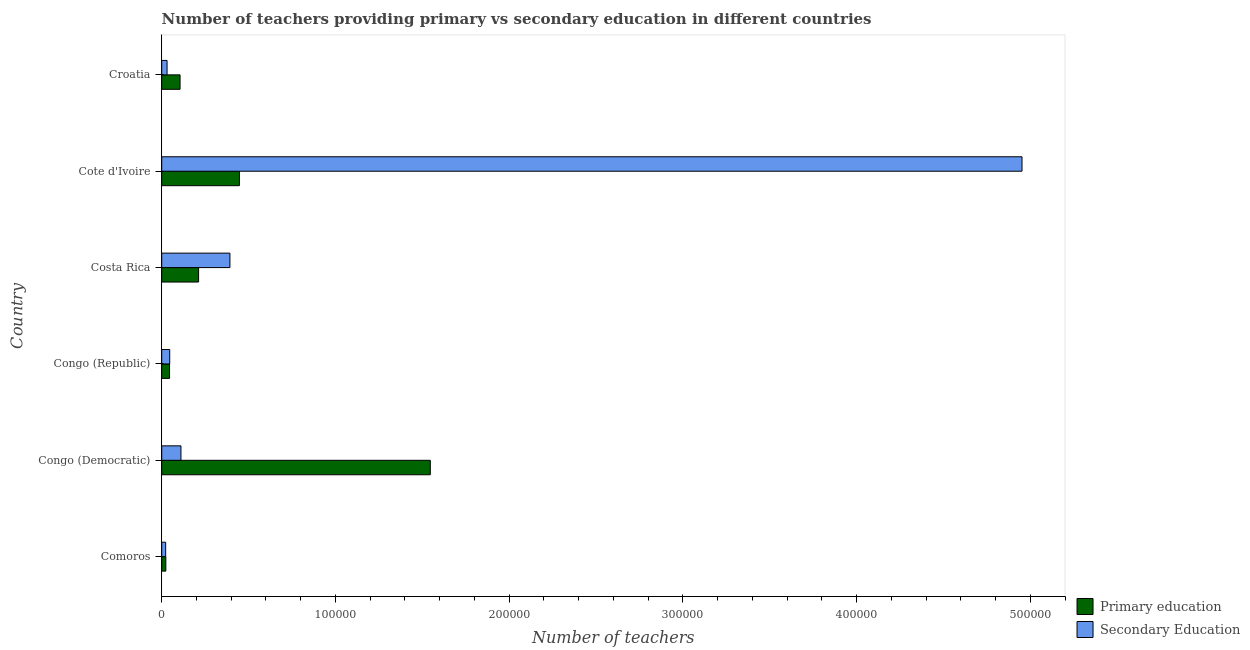Are the number of bars per tick equal to the number of legend labels?
Give a very brief answer. Yes. What is the label of the 2nd group of bars from the top?
Provide a succinct answer. Cote d'Ivoire. What is the number of secondary teachers in Croatia?
Your answer should be compact. 3078. Across all countries, what is the maximum number of primary teachers?
Give a very brief answer. 1.55e+05. Across all countries, what is the minimum number of primary teachers?
Offer a terse response. 2381. In which country was the number of secondary teachers maximum?
Provide a succinct answer. Cote d'Ivoire. In which country was the number of secondary teachers minimum?
Provide a succinct answer. Comoros. What is the total number of primary teachers in the graph?
Your response must be concise. 2.38e+05. What is the difference between the number of secondary teachers in Costa Rica and that in Croatia?
Provide a succinct answer. 3.62e+04. What is the difference between the number of secondary teachers in Croatia and the number of primary teachers in Congo (Democratic)?
Keep it short and to the point. -1.52e+05. What is the average number of secondary teachers per country?
Make the answer very short. 9.26e+04. What is the difference between the number of secondary teachers and number of primary teachers in Costa Rica?
Make the answer very short. 1.80e+04. What is the ratio of the number of primary teachers in Costa Rica to that in Croatia?
Ensure brevity in your answer.  2.01. Is the number of secondary teachers in Costa Rica less than that in Cote d'Ivoire?
Keep it short and to the point. Yes. What is the difference between the highest and the second highest number of secondary teachers?
Give a very brief answer. 4.56e+05. What is the difference between the highest and the lowest number of secondary teachers?
Offer a terse response. 4.93e+05. In how many countries, is the number of secondary teachers greater than the average number of secondary teachers taken over all countries?
Offer a terse response. 1. Is the sum of the number of primary teachers in Costa Rica and Cote d'Ivoire greater than the maximum number of secondary teachers across all countries?
Offer a very short reply. No. What does the 2nd bar from the top in Cote d'Ivoire represents?
Give a very brief answer. Primary education. What does the 2nd bar from the bottom in Congo (Republic) represents?
Provide a short and direct response. Secondary Education. How many bars are there?
Keep it short and to the point. 12. Are all the bars in the graph horizontal?
Offer a very short reply. Yes. Are the values on the major ticks of X-axis written in scientific E-notation?
Make the answer very short. No. Does the graph contain any zero values?
Ensure brevity in your answer.  No. How many legend labels are there?
Keep it short and to the point. 2. How are the legend labels stacked?
Your answer should be very brief. Vertical. What is the title of the graph?
Offer a very short reply. Number of teachers providing primary vs secondary education in different countries. Does "GDP per capita" appear as one of the legend labels in the graph?
Offer a terse response. No. What is the label or title of the X-axis?
Ensure brevity in your answer.  Number of teachers. What is the Number of teachers of Primary education in Comoros?
Your answer should be compact. 2381. What is the Number of teachers of Secondary Education in Comoros?
Provide a short and direct response. 2278. What is the Number of teachers of Primary education in Congo (Democratic)?
Offer a terse response. 1.55e+05. What is the Number of teachers in Secondary Education in Congo (Democratic)?
Give a very brief answer. 1.11e+04. What is the Number of teachers of Primary education in Congo (Republic)?
Ensure brevity in your answer.  4515. What is the Number of teachers in Secondary Education in Congo (Republic)?
Offer a terse response. 4609. What is the Number of teachers of Primary education in Costa Rica?
Your answer should be very brief. 2.12e+04. What is the Number of teachers of Secondary Education in Costa Rica?
Give a very brief answer. 3.93e+04. What is the Number of teachers in Primary education in Cote d'Ivoire?
Your answer should be very brief. 4.47e+04. What is the Number of teachers of Secondary Education in Cote d'Ivoire?
Provide a succinct answer. 4.95e+05. What is the Number of teachers of Primary education in Croatia?
Offer a terse response. 1.06e+04. What is the Number of teachers in Secondary Education in Croatia?
Provide a short and direct response. 3078. Across all countries, what is the maximum Number of teachers of Primary education?
Your answer should be very brief. 1.55e+05. Across all countries, what is the maximum Number of teachers of Secondary Education?
Provide a succinct answer. 4.95e+05. Across all countries, what is the minimum Number of teachers of Primary education?
Offer a very short reply. 2381. Across all countries, what is the minimum Number of teachers of Secondary Education?
Your answer should be compact. 2278. What is the total Number of teachers in Primary education in the graph?
Keep it short and to the point. 2.38e+05. What is the total Number of teachers in Secondary Education in the graph?
Your response must be concise. 5.56e+05. What is the difference between the Number of teachers in Primary education in Comoros and that in Congo (Democratic)?
Provide a short and direct response. -1.52e+05. What is the difference between the Number of teachers in Secondary Education in Comoros and that in Congo (Democratic)?
Offer a terse response. -8797. What is the difference between the Number of teachers of Primary education in Comoros and that in Congo (Republic)?
Provide a succinct answer. -2134. What is the difference between the Number of teachers in Secondary Education in Comoros and that in Congo (Republic)?
Your answer should be very brief. -2331. What is the difference between the Number of teachers in Primary education in Comoros and that in Costa Rica?
Offer a terse response. -1.89e+04. What is the difference between the Number of teachers of Secondary Education in Comoros and that in Costa Rica?
Your answer should be very brief. -3.70e+04. What is the difference between the Number of teachers in Primary education in Comoros and that in Cote d'Ivoire?
Your answer should be very brief. -4.24e+04. What is the difference between the Number of teachers in Secondary Education in Comoros and that in Cote d'Ivoire?
Make the answer very short. -4.93e+05. What is the difference between the Number of teachers in Primary education in Comoros and that in Croatia?
Your answer should be compact. -8187. What is the difference between the Number of teachers in Secondary Education in Comoros and that in Croatia?
Make the answer very short. -800. What is the difference between the Number of teachers in Primary education in Congo (Democratic) and that in Congo (Republic)?
Make the answer very short. 1.50e+05. What is the difference between the Number of teachers in Secondary Education in Congo (Democratic) and that in Congo (Republic)?
Your answer should be compact. 6466. What is the difference between the Number of teachers in Primary education in Congo (Democratic) and that in Costa Rica?
Your answer should be compact. 1.33e+05. What is the difference between the Number of teachers of Secondary Education in Congo (Democratic) and that in Costa Rica?
Your answer should be very brief. -2.82e+04. What is the difference between the Number of teachers in Primary education in Congo (Democratic) and that in Cote d'Ivoire?
Your answer should be compact. 1.10e+05. What is the difference between the Number of teachers of Secondary Education in Congo (Democratic) and that in Cote d'Ivoire?
Your response must be concise. -4.84e+05. What is the difference between the Number of teachers in Primary education in Congo (Democratic) and that in Croatia?
Keep it short and to the point. 1.44e+05. What is the difference between the Number of teachers of Secondary Education in Congo (Democratic) and that in Croatia?
Provide a succinct answer. 7997. What is the difference between the Number of teachers of Primary education in Congo (Republic) and that in Costa Rica?
Provide a succinct answer. -1.67e+04. What is the difference between the Number of teachers in Secondary Education in Congo (Republic) and that in Costa Rica?
Give a very brief answer. -3.47e+04. What is the difference between the Number of teachers in Primary education in Congo (Republic) and that in Cote d'Ivoire?
Provide a short and direct response. -4.02e+04. What is the difference between the Number of teachers of Secondary Education in Congo (Republic) and that in Cote d'Ivoire?
Give a very brief answer. -4.91e+05. What is the difference between the Number of teachers of Primary education in Congo (Republic) and that in Croatia?
Ensure brevity in your answer.  -6053. What is the difference between the Number of teachers of Secondary Education in Congo (Republic) and that in Croatia?
Offer a terse response. 1531. What is the difference between the Number of teachers of Primary education in Costa Rica and that in Cote d'Ivoire?
Your answer should be compact. -2.35e+04. What is the difference between the Number of teachers in Secondary Education in Costa Rica and that in Cote d'Ivoire?
Your answer should be compact. -4.56e+05. What is the difference between the Number of teachers of Primary education in Costa Rica and that in Croatia?
Give a very brief answer. 1.07e+04. What is the difference between the Number of teachers in Secondary Education in Costa Rica and that in Croatia?
Make the answer very short. 3.62e+04. What is the difference between the Number of teachers in Primary education in Cote d'Ivoire and that in Croatia?
Ensure brevity in your answer.  3.42e+04. What is the difference between the Number of teachers in Secondary Education in Cote d'Ivoire and that in Croatia?
Your answer should be very brief. 4.92e+05. What is the difference between the Number of teachers in Primary education in Comoros and the Number of teachers in Secondary Education in Congo (Democratic)?
Give a very brief answer. -8694. What is the difference between the Number of teachers of Primary education in Comoros and the Number of teachers of Secondary Education in Congo (Republic)?
Provide a succinct answer. -2228. What is the difference between the Number of teachers of Primary education in Comoros and the Number of teachers of Secondary Education in Costa Rica?
Offer a terse response. -3.69e+04. What is the difference between the Number of teachers in Primary education in Comoros and the Number of teachers in Secondary Education in Cote d'Ivoire?
Give a very brief answer. -4.93e+05. What is the difference between the Number of teachers of Primary education in Comoros and the Number of teachers of Secondary Education in Croatia?
Make the answer very short. -697. What is the difference between the Number of teachers of Primary education in Congo (Democratic) and the Number of teachers of Secondary Education in Congo (Republic)?
Provide a short and direct response. 1.50e+05. What is the difference between the Number of teachers of Primary education in Congo (Democratic) and the Number of teachers of Secondary Education in Costa Rica?
Keep it short and to the point. 1.15e+05. What is the difference between the Number of teachers of Primary education in Congo (Democratic) and the Number of teachers of Secondary Education in Cote d'Ivoire?
Ensure brevity in your answer.  -3.41e+05. What is the difference between the Number of teachers of Primary education in Congo (Democratic) and the Number of teachers of Secondary Education in Croatia?
Offer a terse response. 1.52e+05. What is the difference between the Number of teachers in Primary education in Congo (Republic) and the Number of teachers in Secondary Education in Costa Rica?
Make the answer very short. -3.48e+04. What is the difference between the Number of teachers in Primary education in Congo (Republic) and the Number of teachers in Secondary Education in Cote d'Ivoire?
Keep it short and to the point. -4.91e+05. What is the difference between the Number of teachers in Primary education in Congo (Republic) and the Number of teachers in Secondary Education in Croatia?
Provide a short and direct response. 1437. What is the difference between the Number of teachers in Primary education in Costa Rica and the Number of teachers in Secondary Education in Cote d'Ivoire?
Offer a very short reply. -4.74e+05. What is the difference between the Number of teachers of Primary education in Costa Rica and the Number of teachers of Secondary Education in Croatia?
Your answer should be compact. 1.82e+04. What is the difference between the Number of teachers of Primary education in Cote d'Ivoire and the Number of teachers of Secondary Education in Croatia?
Provide a succinct answer. 4.17e+04. What is the average Number of teachers in Primary education per country?
Offer a very short reply. 3.97e+04. What is the average Number of teachers of Secondary Education per country?
Provide a succinct answer. 9.26e+04. What is the difference between the Number of teachers in Primary education and Number of teachers in Secondary Education in Comoros?
Your response must be concise. 103. What is the difference between the Number of teachers of Primary education and Number of teachers of Secondary Education in Congo (Democratic)?
Offer a terse response. 1.44e+05. What is the difference between the Number of teachers in Primary education and Number of teachers in Secondary Education in Congo (Republic)?
Offer a very short reply. -94. What is the difference between the Number of teachers in Primary education and Number of teachers in Secondary Education in Costa Rica?
Your answer should be very brief. -1.80e+04. What is the difference between the Number of teachers of Primary education and Number of teachers of Secondary Education in Cote d'Ivoire?
Make the answer very short. -4.51e+05. What is the difference between the Number of teachers of Primary education and Number of teachers of Secondary Education in Croatia?
Ensure brevity in your answer.  7490. What is the ratio of the Number of teachers of Primary education in Comoros to that in Congo (Democratic)?
Provide a succinct answer. 0.02. What is the ratio of the Number of teachers of Secondary Education in Comoros to that in Congo (Democratic)?
Give a very brief answer. 0.21. What is the ratio of the Number of teachers in Primary education in Comoros to that in Congo (Republic)?
Your response must be concise. 0.53. What is the ratio of the Number of teachers in Secondary Education in Comoros to that in Congo (Republic)?
Offer a terse response. 0.49. What is the ratio of the Number of teachers of Primary education in Comoros to that in Costa Rica?
Offer a very short reply. 0.11. What is the ratio of the Number of teachers in Secondary Education in Comoros to that in Costa Rica?
Offer a terse response. 0.06. What is the ratio of the Number of teachers of Primary education in Comoros to that in Cote d'Ivoire?
Your answer should be compact. 0.05. What is the ratio of the Number of teachers of Secondary Education in Comoros to that in Cote d'Ivoire?
Your answer should be very brief. 0. What is the ratio of the Number of teachers in Primary education in Comoros to that in Croatia?
Keep it short and to the point. 0.23. What is the ratio of the Number of teachers of Secondary Education in Comoros to that in Croatia?
Keep it short and to the point. 0.74. What is the ratio of the Number of teachers in Primary education in Congo (Democratic) to that in Congo (Republic)?
Your response must be concise. 34.25. What is the ratio of the Number of teachers of Secondary Education in Congo (Democratic) to that in Congo (Republic)?
Provide a succinct answer. 2.4. What is the ratio of the Number of teachers in Primary education in Congo (Democratic) to that in Costa Rica?
Provide a succinct answer. 7.28. What is the ratio of the Number of teachers of Secondary Education in Congo (Democratic) to that in Costa Rica?
Offer a very short reply. 0.28. What is the ratio of the Number of teachers in Primary education in Congo (Democratic) to that in Cote d'Ivoire?
Offer a terse response. 3.46. What is the ratio of the Number of teachers of Secondary Education in Congo (Democratic) to that in Cote d'Ivoire?
Your response must be concise. 0.02. What is the ratio of the Number of teachers of Primary education in Congo (Democratic) to that in Croatia?
Keep it short and to the point. 14.63. What is the ratio of the Number of teachers of Secondary Education in Congo (Democratic) to that in Croatia?
Your answer should be compact. 3.6. What is the ratio of the Number of teachers of Primary education in Congo (Republic) to that in Costa Rica?
Offer a very short reply. 0.21. What is the ratio of the Number of teachers of Secondary Education in Congo (Republic) to that in Costa Rica?
Give a very brief answer. 0.12. What is the ratio of the Number of teachers in Primary education in Congo (Republic) to that in Cote d'Ivoire?
Offer a very short reply. 0.1. What is the ratio of the Number of teachers of Secondary Education in Congo (Republic) to that in Cote d'Ivoire?
Offer a very short reply. 0.01. What is the ratio of the Number of teachers in Primary education in Congo (Republic) to that in Croatia?
Provide a short and direct response. 0.43. What is the ratio of the Number of teachers in Secondary Education in Congo (Republic) to that in Croatia?
Your answer should be compact. 1.5. What is the ratio of the Number of teachers in Primary education in Costa Rica to that in Cote d'Ivoire?
Your response must be concise. 0.47. What is the ratio of the Number of teachers in Secondary Education in Costa Rica to that in Cote d'Ivoire?
Make the answer very short. 0.08. What is the ratio of the Number of teachers in Primary education in Costa Rica to that in Croatia?
Keep it short and to the point. 2.01. What is the ratio of the Number of teachers in Secondary Education in Costa Rica to that in Croatia?
Give a very brief answer. 12.76. What is the ratio of the Number of teachers of Primary education in Cote d'Ivoire to that in Croatia?
Offer a terse response. 4.23. What is the ratio of the Number of teachers of Secondary Education in Cote d'Ivoire to that in Croatia?
Provide a succinct answer. 160.9. What is the difference between the highest and the second highest Number of teachers in Primary education?
Give a very brief answer. 1.10e+05. What is the difference between the highest and the second highest Number of teachers of Secondary Education?
Your response must be concise. 4.56e+05. What is the difference between the highest and the lowest Number of teachers in Primary education?
Your answer should be compact. 1.52e+05. What is the difference between the highest and the lowest Number of teachers of Secondary Education?
Ensure brevity in your answer.  4.93e+05. 